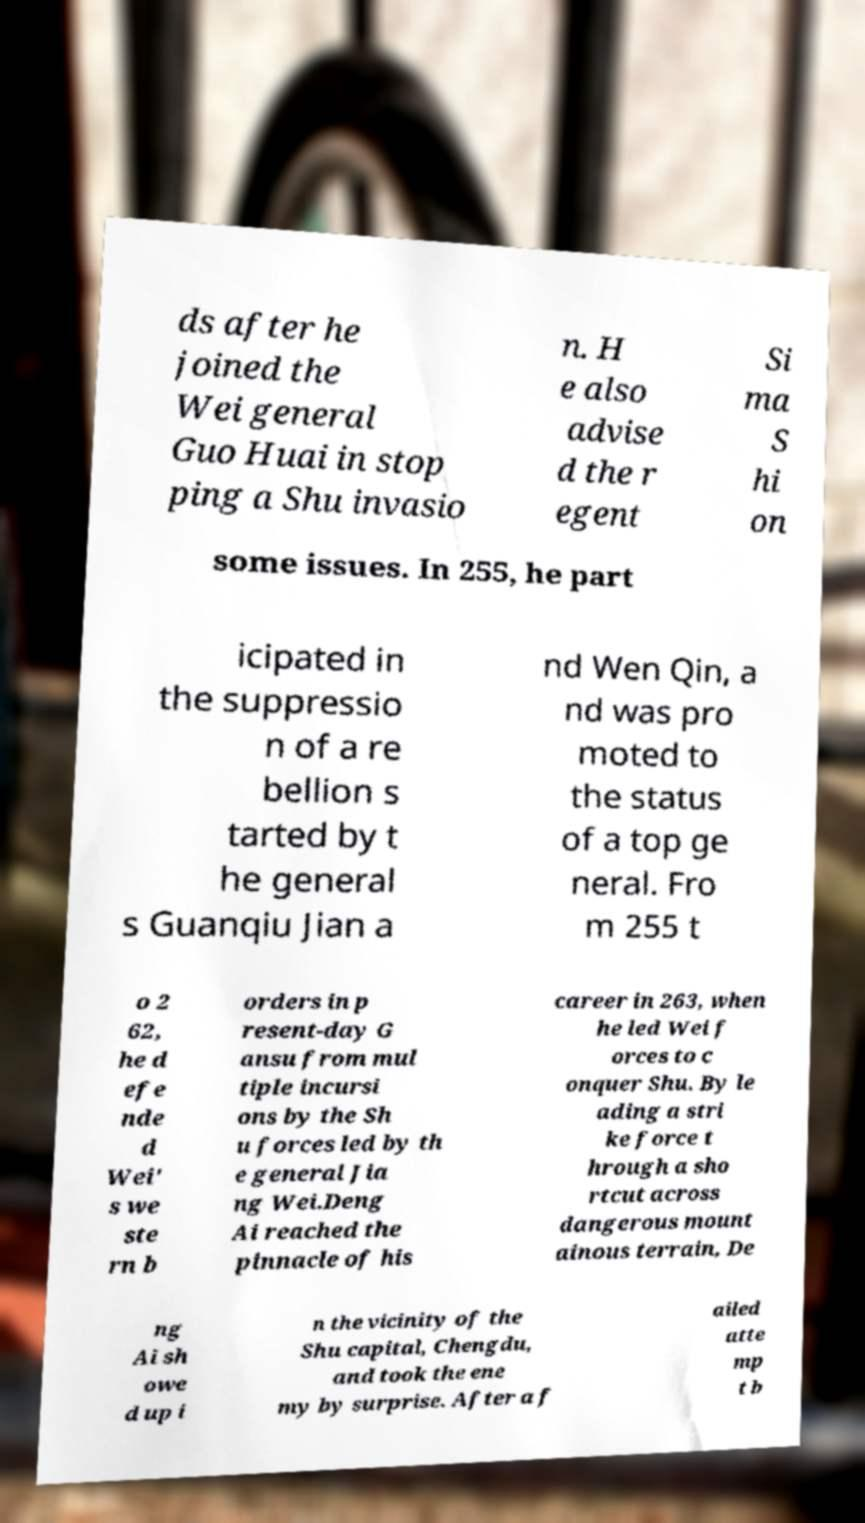Could you assist in decoding the text presented in this image and type it out clearly? ds after he joined the Wei general Guo Huai in stop ping a Shu invasio n. H e also advise d the r egent Si ma S hi on some issues. In 255, he part icipated in the suppressio n of a re bellion s tarted by t he general s Guanqiu Jian a nd Wen Qin, a nd was pro moted to the status of a top ge neral. Fro m 255 t o 2 62, he d efe nde d Wei' s we ste rn b orders in p resent-day G ansu from mul tiple incursi ons by the Sh u forces led by th e general Jia ng Wei.Deng Ai reached the pinnacle of his career in 263, when he led Wei f orces to c onquer Shu. By le ading a stri ke force t hrough a sho rtcut across dangerous mount ainous terrain, De ng Ai sh owe d up i n the vicinity of the Shu capital, Chengdu, and took the ene my by surprise. After a f ailed atte mp t b 